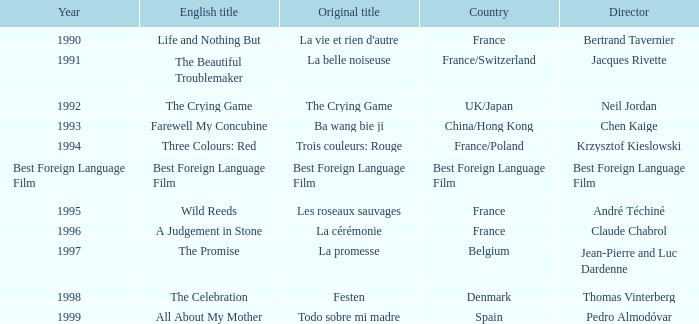What's the English title listed that has an Original title of The Crying Game? The Crying Game. 